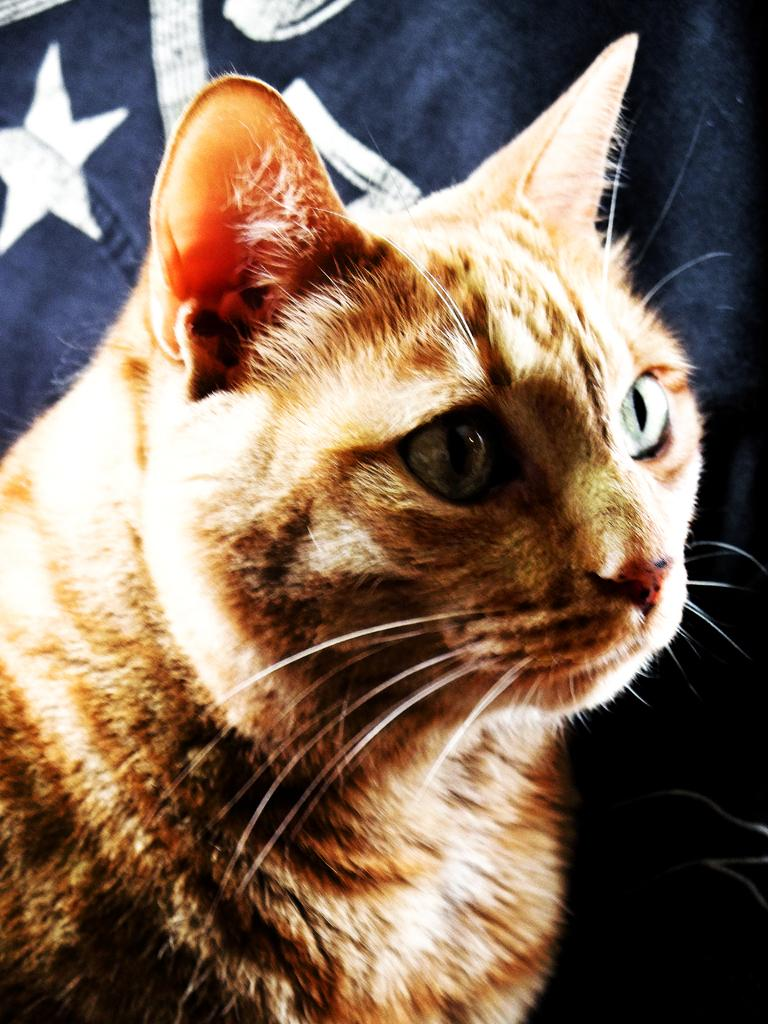What type of animal is in the image? There is a cat in the image. What type of umbrella is the cat holding in the image? There is no umbrella present in the image, and the cat is not holding anything. 